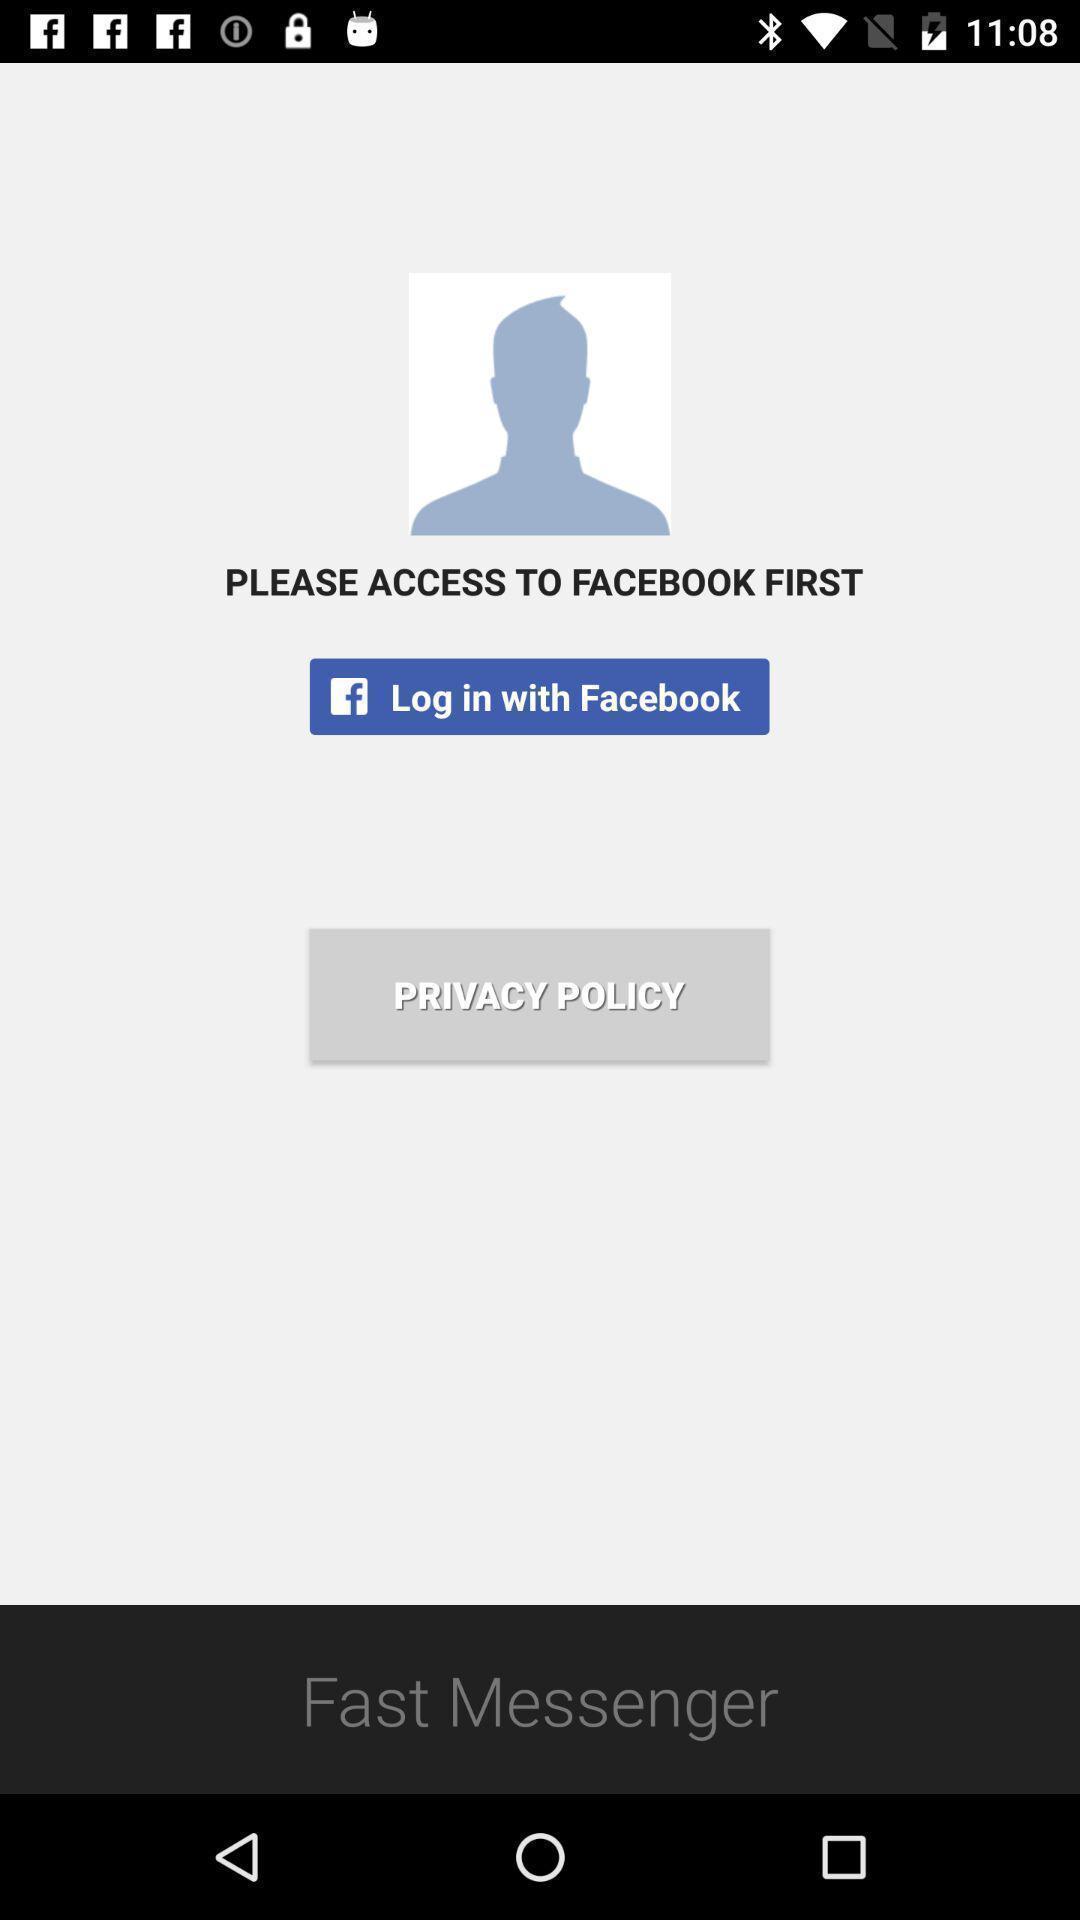Describe the content in this image. Welcome page. 